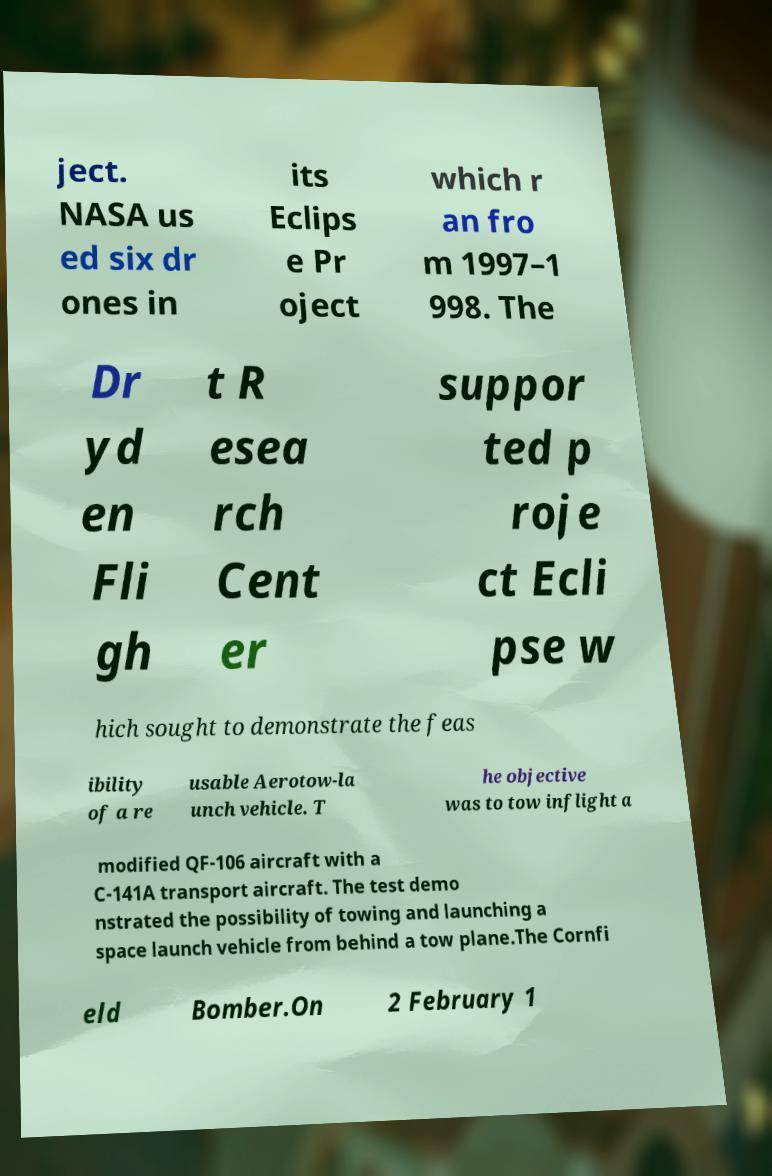Can you accurately transcribe the text from the provided image for me? ject. NASA us ed six dr ones in its Eclips e Pr oject which r an fro m 1997–1 998. The Dr yd en Fli gh t R esea rch Cent er suppor ted p roje ct Ecli pse w hich sought to demonstrate the feas ibility of a re usable Aerotow-la unch vehicle. T he objective was to tow inflight a modified QF-106 aircraft with a C-141A transport aircraft. The test demo nstrated the possibility of towing and launching a space launch vehicle from behind a tow plane.The Cornfi eld Bomber.On 2 February 1 